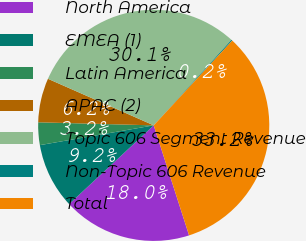<chart> <loc_0><loc_0><loc_500><loc_500><pie_chart><fcel>North America<fcel>EMEA (1)<fcel>Latin America<fcel>APAC (2)<fcel>Topic 606 Segment Revenue<fcel>Non-Topic 606 Revenue<fcel>Total<nl><fcel>18.02%<fcel>9.19%<fcel>3.16%<fcel>6.18%<fcel>30.14%<fcel>0.15%<fcel>33.16%<nl></chart> 